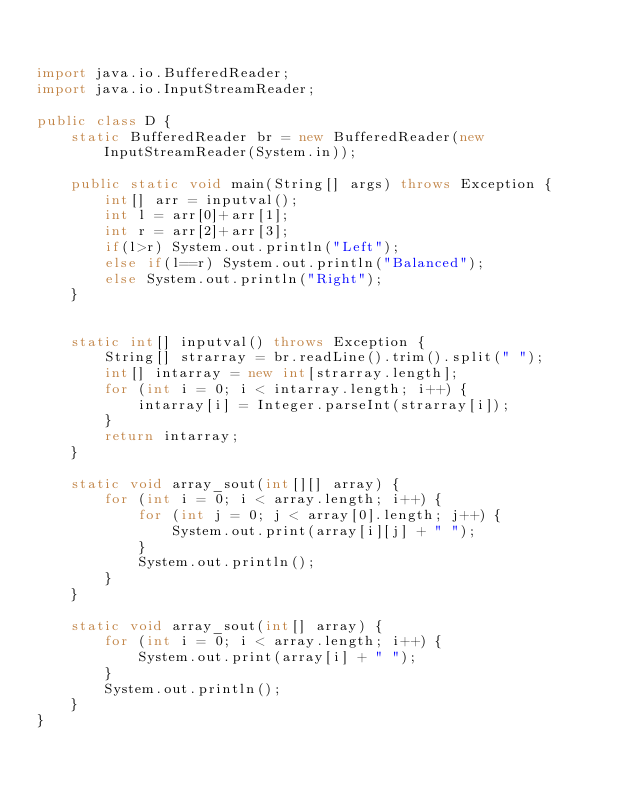<code> <loc_0><loc_0><loc_500><loc_500><_Java_>

import java.io.BufferedReader;
import java.io.InputStreamReader;

public class D {
    static BufferedReader br = new BufferedReader(new InputStreamReader(System.in));

    public static void main(String[] args) throws Exception {
        int[] arr = inputval();
        int l = arr[0]+arr[1];
        int r = arr[2]+arr[3];
        if(l>r) System.out.println("Left");
        else if(l==r) System.out.println("Balanced");
        else System.out.println("Right");
    }


    static int[] inputval() throws Exception {
        String[] strarray = br.readLine().trim().split(" ");
        int[] intarray = new int[strarray.length];
        for (int i = 0; i < intarray.length; i++) {
            intarray[i] = Integer.parseInt(strarray[i]);
        }
        return intarray;
    }

    static void array_sout(int[][] array) {
        for (int i = 0; i < array.length; i++) {
            for (int j = 0; j < array[0].length; j++) {
                System.out.print(array[i][j] + " ");
            }
            System.out.println();
        }
    }

    static void array_sout(int[] array) {
        for (int i = 0; i < array.length; i++) {
            System.out.print(array[i] + " ");
        }
        System.out.println();
    }
}</code> 